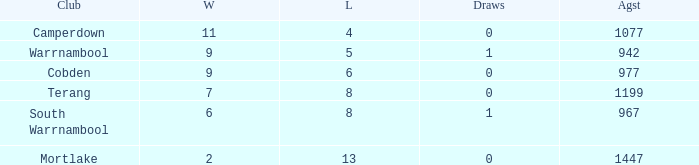What is the draw when the losses were more than 8 and less than 2 wins? None. 